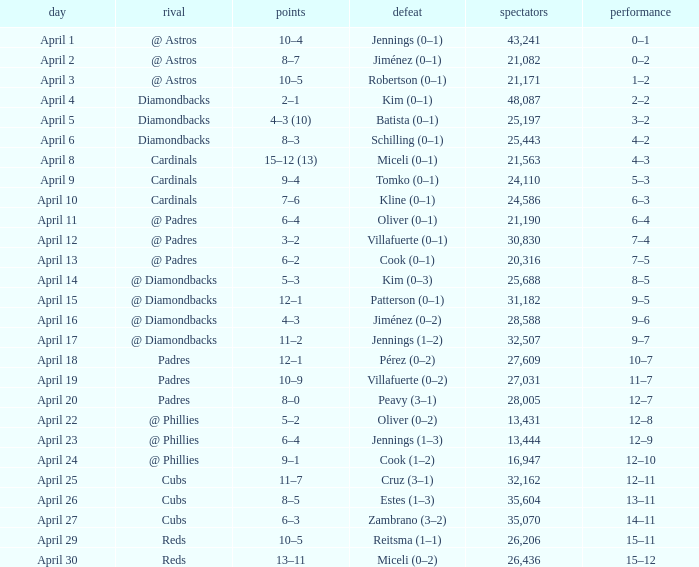Who is the opponent on april 16? @ Diamondbacks. 